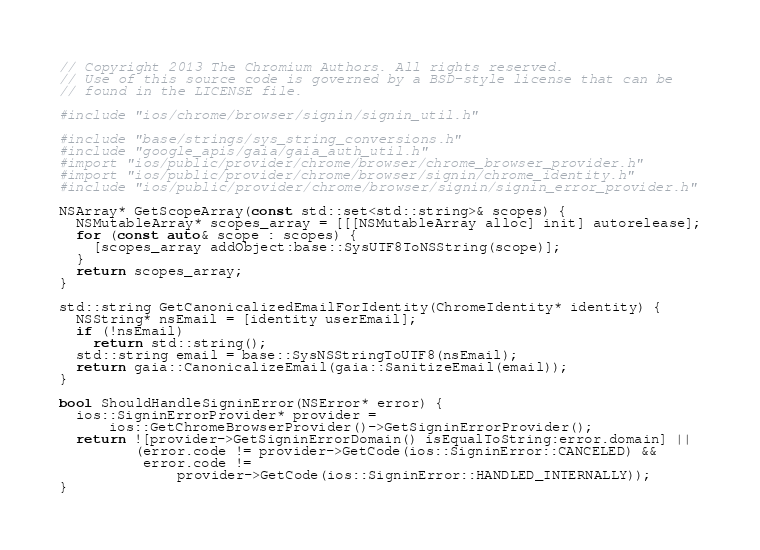<code> <loc_0><loc_0><loc_500><loc_500><_ObjectiveC_>// Copyright 2013 The Chromium Authors. All rights reserved.
// Use of this source code is governed by a BSD-style license that can be
// found in the LICENSE file.

#include "ios/chrome/browser/signin/signin_util.h"

#include "base/strings/sys_string_conversions.h"
#include "google_apis/gaia/gaia_auth_util.h"
#import "ios/public/provider/chrome/browser/chrome_browser_provider.h"
#import "ios/public/provider/chrome/browser/signin/chrome_identity.h"
#include "ios/public/provider/chrome/browser/signin/signin_error_provider.h"

NSArray* GetScopeArray(const std::set<std::string>& scopes) {
  NSMutableArray* scopes_array = [[[NSMutableArray alloc] init] autorelease];
  for (const auto& scope : scopes) {
    [scopes_array addObject:base::SysUTF8ToNSString(scope)];
  }
  return scopes_array;
}

std::string GetCanonicalizedEmailForIdentity(ChromeIdentity* identity) {
  NSString* nsEmail = [identity userEmail];
  if (!nsEmail)
    return std::string();
  std::string email = base::SysNSStringToUTF8(nsEmail);
  return gaia::CanonicalizeEmail(gaia::SanitizeEmail(email));
}

bool ShouldHandleSigninError(NSError* error) {
  ios::SigninErrorProvider* provider =
      ios::GetChromeBrowserProvider()->GetSigninErrorProvider();
  return ![provider->GetSigninErrorDomain() isEqualToString:error.domain] ||
         (error.code != provider->GetCode(ios::SigninError::CANCELED) &&
          error.code !=
              provider->GetCode(ios::SigninError::HANDLED_INTERNALLY));
}
</code> 